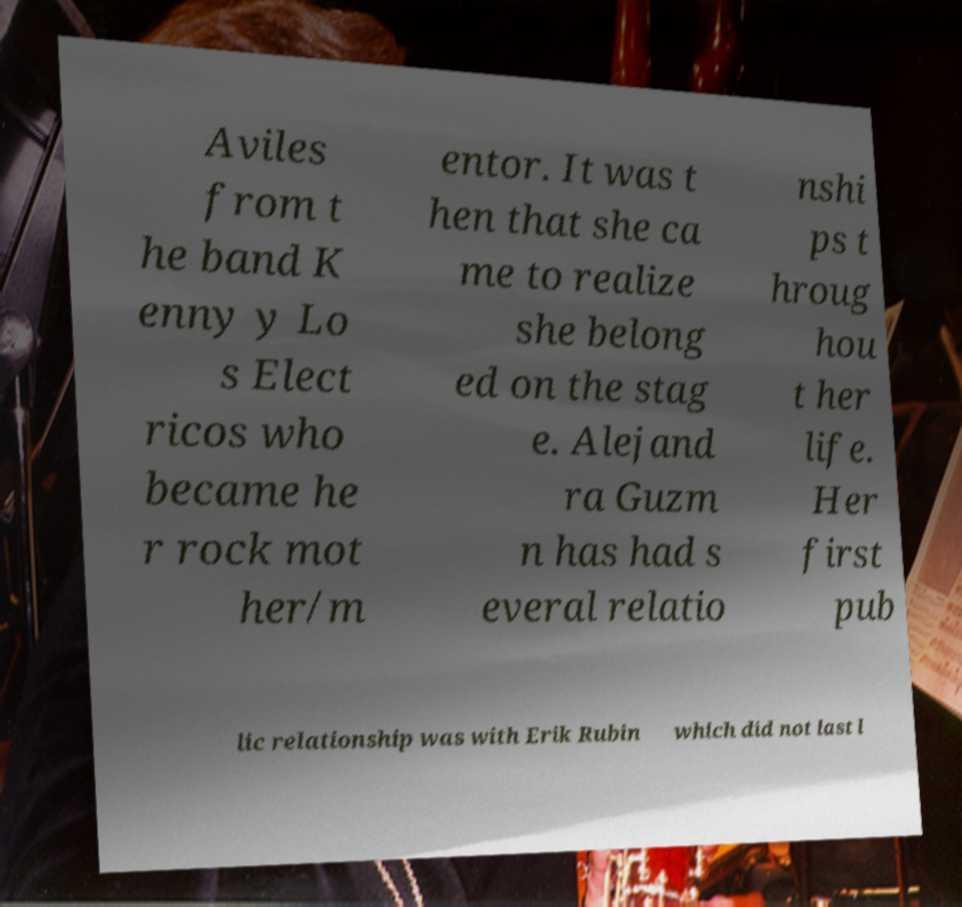There's text embedded in this image that I need extracted. Can you transcribe it verbatim? Aviles from t he band K enny y Lo s Elect ricos who became he r rock mot her/m entor. It was t hen that she ca me to realize she belong ed on the stag e. Alejand ra Guzm n has had s everal relatio nshi ps t hroug hou t her life. Her first pub lic relationship was with Erik Rubin which did not last l 